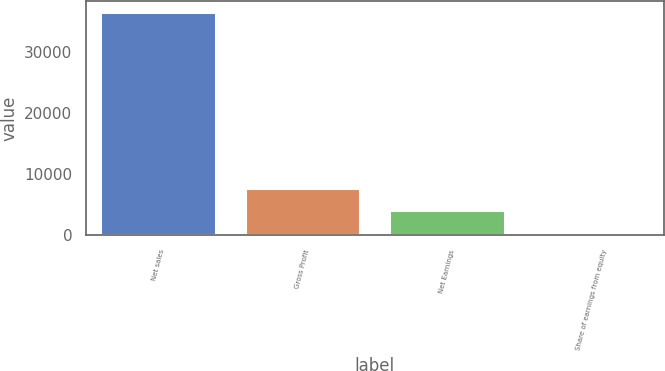<chart> <loc_0><loc_0><loc_500><loc_500><bar_chart><fcel>Net sales<fcel>Gross Profit<fcel>Net Earnings<fcel>Share of earnings from equity<nl><fcel>36482<fcel>7693.2<fcel>4094.6<fcel>496<nl></chart> 